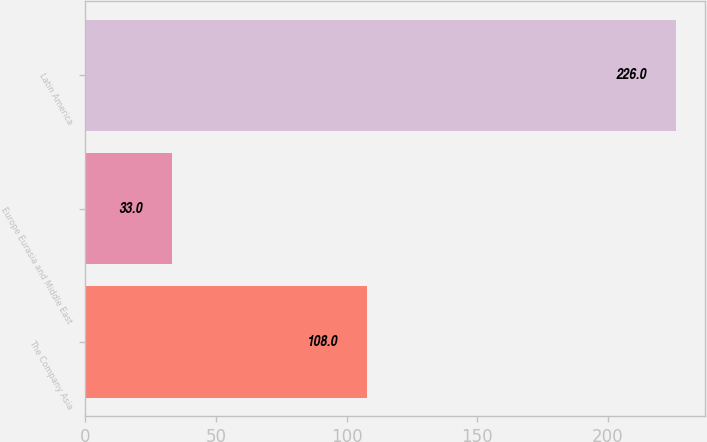<chart> <loc_0><loc_0><loc_500><loc_500><bar_chart><fcel>The Company Asia<fcel>Europe Eurasia and Middle East<fcel>Latin America<nl><fcel>108<fcel>33<fcel>226<nl></chart> 